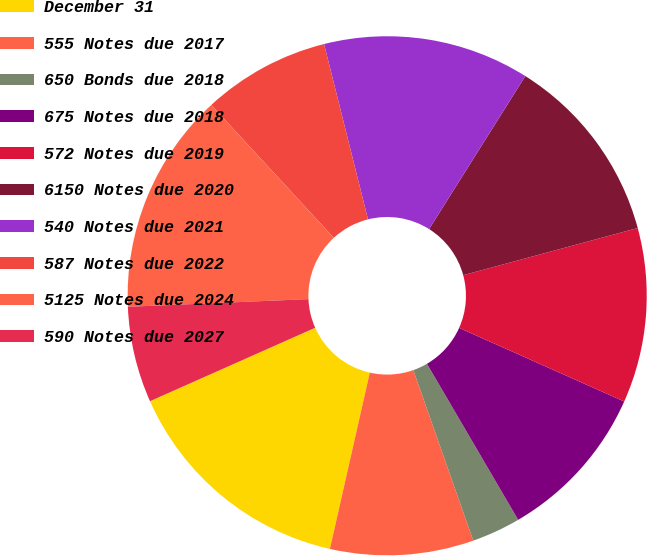Convert chart. <chart><loc_0><loc_0><loc_500><loc_500><pie_chart><fcel>December 31<fcel>555 Notes due 2017<fcel>650 Bonds due 2018<fcel>675 Notes due 2018<fcel>572 Notes due 2019<fcel>6150 Notes due 2020<fcel>540 Notes due 2021<fcel>587 Notes due 2022<fcel>5125 Notes due 2024<fcel>590 Notes due 2027<nl><fcel>14.8%<fcel>8.92%<fcel>3.04%<fcel>9.9%<fcel>10.88%<fcel>11.86%<fcel>12.84%<fcel>7.94%<fcel>13.82%<fcel>5.98%<nl></chart> 